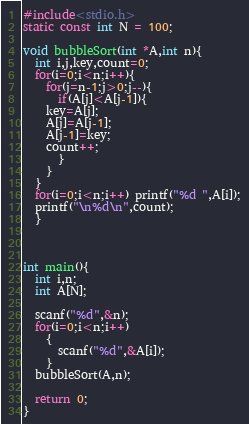<code> <loc_0><loc_0><loc_500><loc_500><_C_>#include<stdio.h>
static const int N = 100;

void bubbleSort(int *A,int n){
  int i,j,key,count=0;
  for(i=0;i<n;i++){
    for(j=n-1;j>0;j--){
      if(A[j]<A[j-1]){
	key=A[j];
	A[j]=A[j-1];
	A[j-1]=key;
	count++;
      }
    }
  }
  for(i=0;i<n;i++) printf("%d ",A[i]);
  printf("\n%d\n",count);
  }


        
int main(){
  int i,n;
  int A[N];

  scanf("%d",&n);
  for(i=0;i<n;i++)
    {
      scanf("%d",&A[i]);
    }
  bubbleSort(A,n);
 
  return 0;
}</code> 